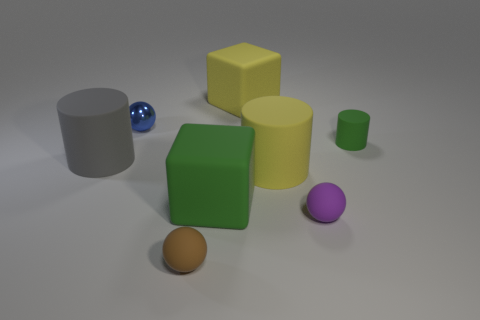Subtract 1 cylinders. How many cylinders are left? 2 Add 2 gray rubber cubes. How many objects exist? 10 Subtract all cubes. How many objects are left? 6 Add 8 small purple matte things. How many small purple matte things are left? 9 Add 5 red metallic cylinders. How many red metallic cylinders exist? 5 Subtract 1 gray cylinders. How many objects are left? 7 Subtract all matte things. Subtract all tiny green matte cubes. How many objects are left? 1 